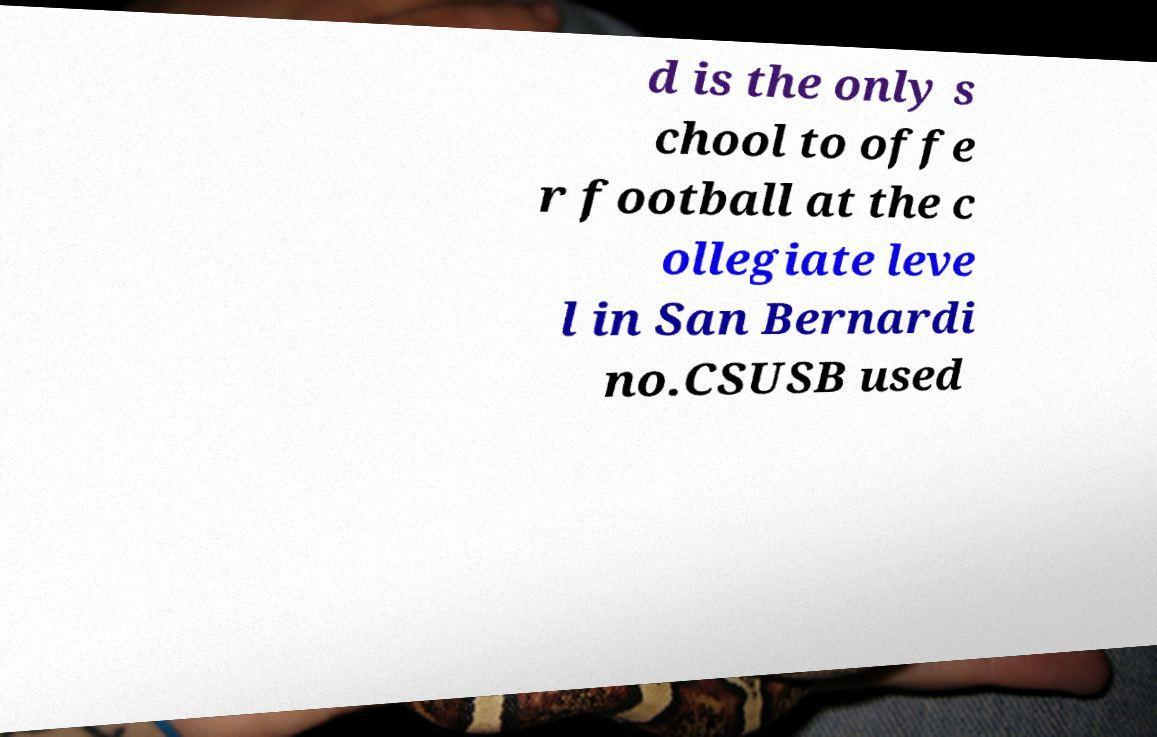Could you assist in decoding the text presented in this image and type it out clearly? d is the only s chool to offe r football at the c ollegiate leve l in San Bernardi no.CSUSB used 